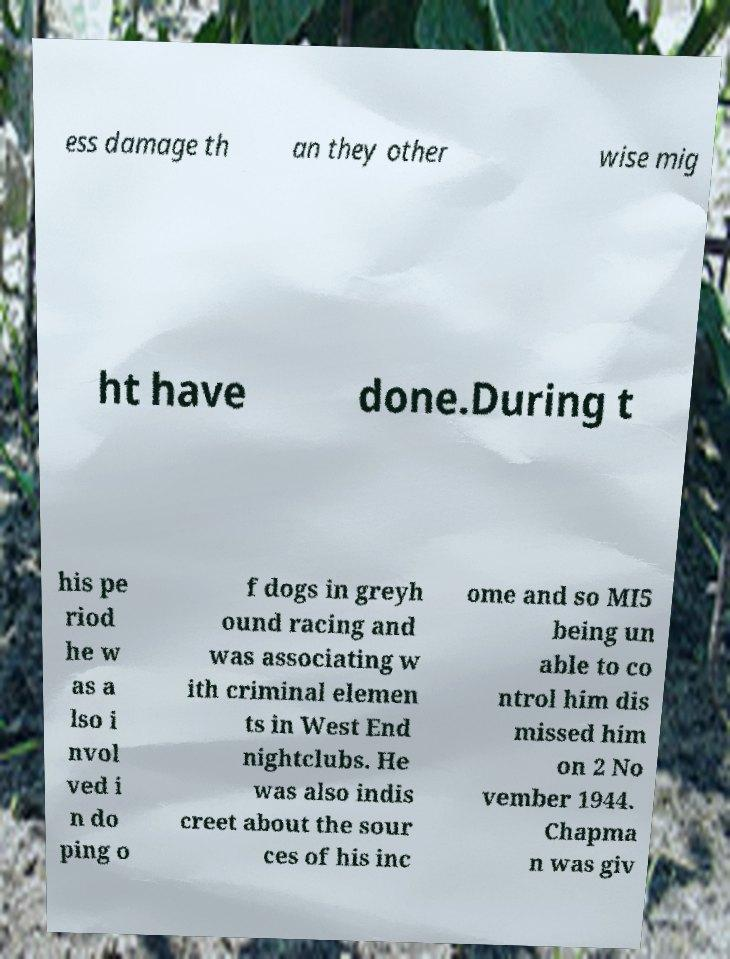Please read and relay the text visible in this image. What does it say? ess damage th an they other wise mig ht have done.During t his pe riod he w as a lso i nvol ved i n do ping o f dogs in greyh ound racing and was associating w ith criminal elemen ts in West End nightclubs. He was also indis creet about the sour ces of his inc ome and so MI5 being un able to co ntrol him dis missed him on 2 No vember 1944. Chapma n was giv 